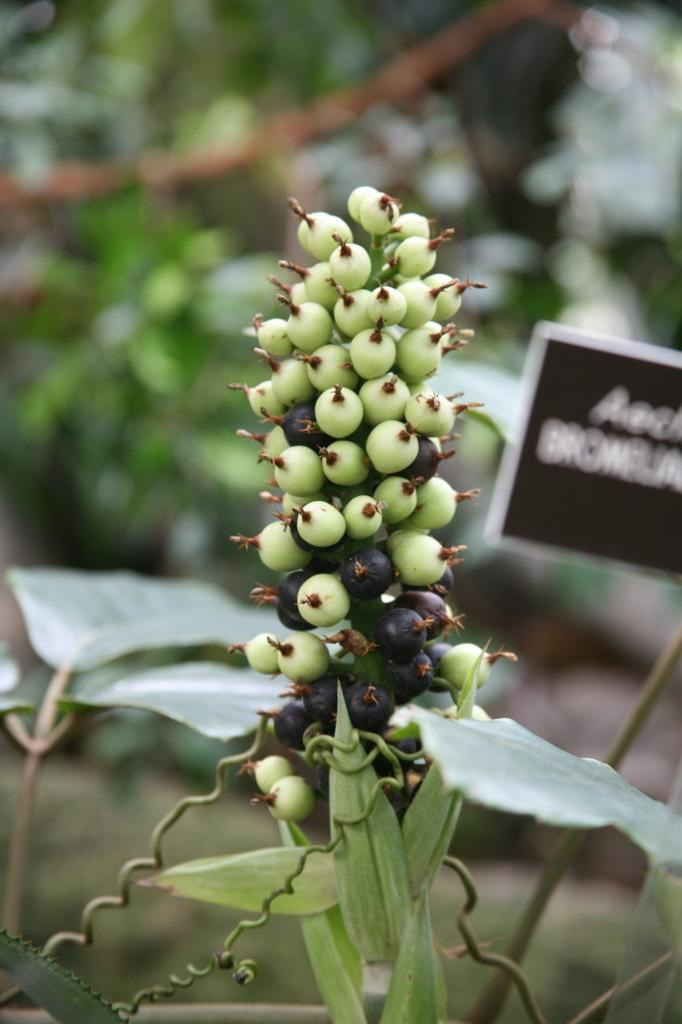What type of plant is visible in the image? There is a plant with fruits in the image. What other object can be seen in the image? There is a board in the image. Can you describe the background of the image? The background of the image is blurred. What color is the tongue of the person sitting on the chair in the image? There is no person or chair present in the image, so it is not possible to determine the color of anyone's tongue. 